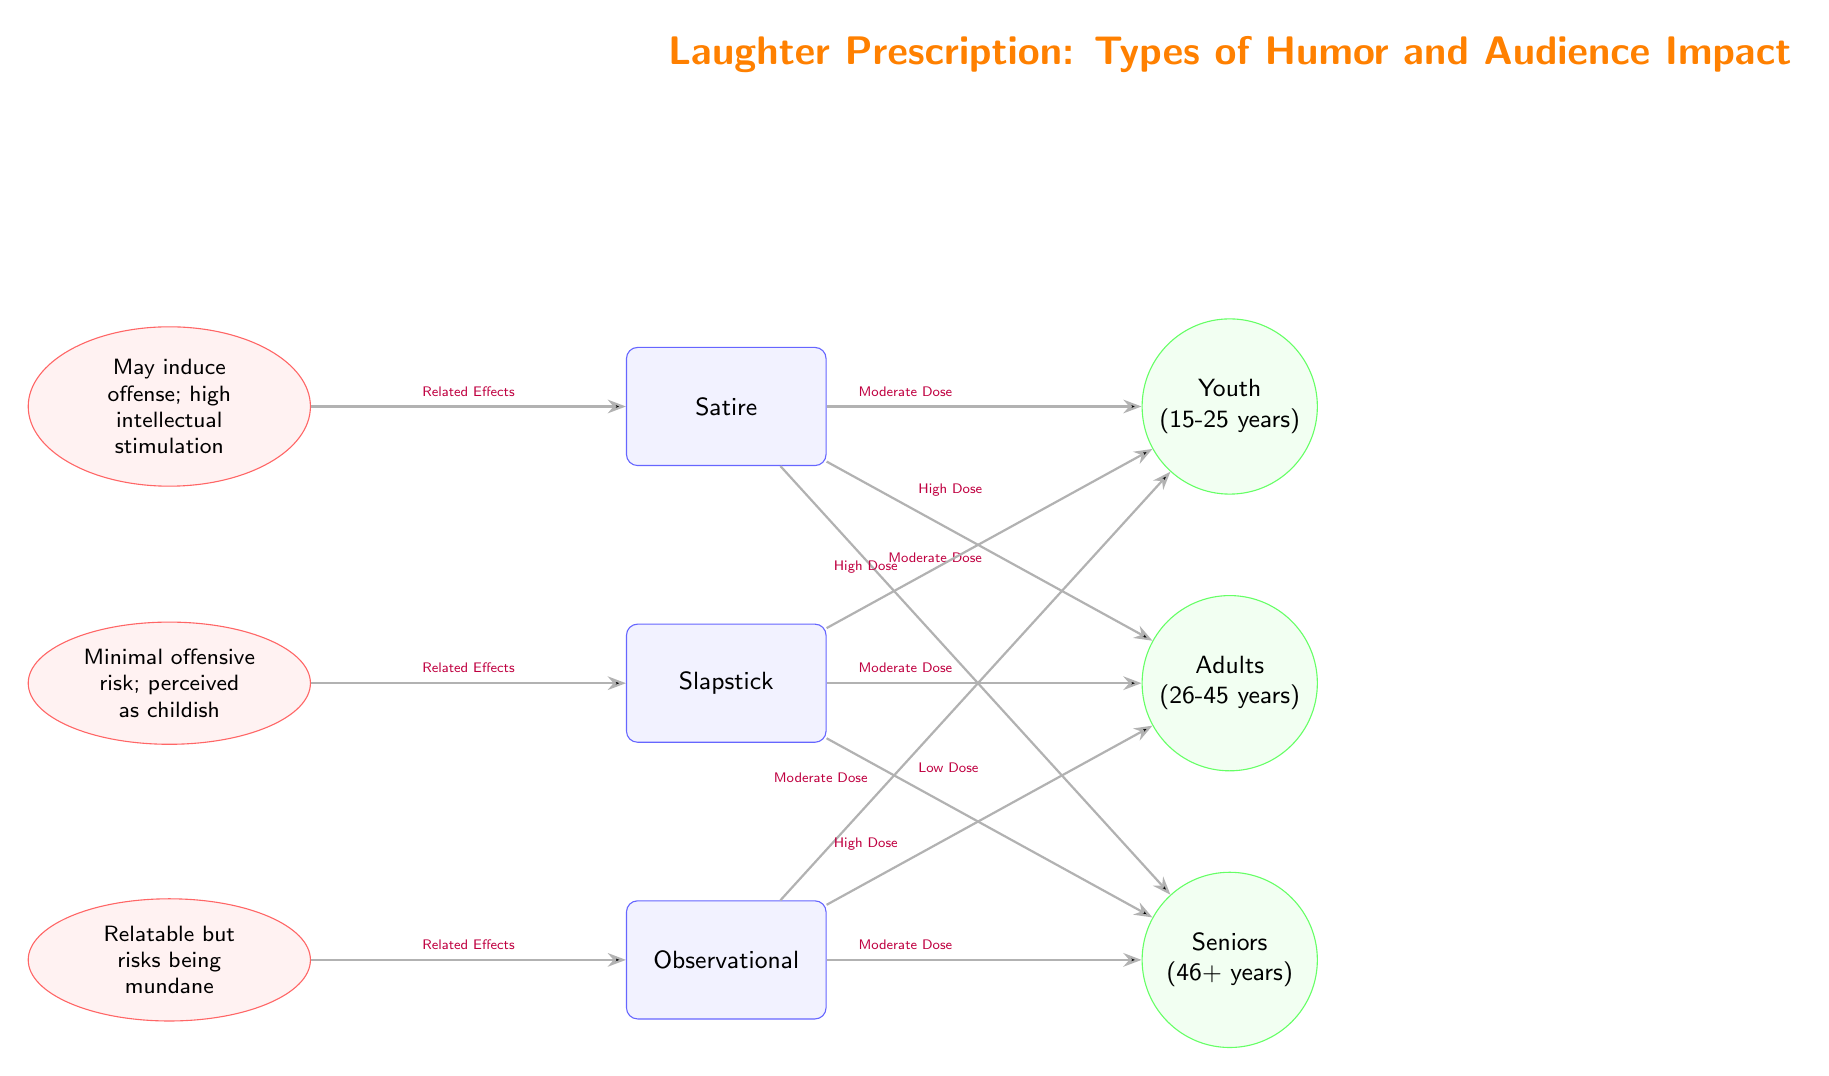What are the types of humor represented in the diagram? The diagram displays three types of humor: Satire, Slapstick, and Observational. This information is directly identifiable by examining the humor nodes at the top of the diagram.
Answer: Satire, Slapstick, Observational Which audience demographic is most likely to enjoy slapstick comedy in high doses? According to the connections depicted in the diagram, the Youth demographic is linked to slapstick comedy with a "High Dose." This relationship is established through the edge connecting the Slapstick node to the Youth node with the specified dose.
Answer: Youth What side effect is associated with satire? The node related to the side effects of satire directly states that it "May induce offense; high intellectual stimulation." This information is found in the side effect node linked to the Satire humor type.
Answer: May induce offense; high intellectual stimulation What is the required dose of observational humor for adults? The diagram indicates that the "High Dose" of observational humor is aimed at the Adults demographic, as shown by the edge connecting the Observational humor node to the Adults audience node and the label on the edge.
Answer: High Dose Which type of humor has minimal offensive risk according to the side effects? The side effect node corresponding to slapstick humor notes that there is "Minimal offensive risk; perceived as childish." This information is directly gleaned from the content of the side effect node linked to Slapstick.
Answer: Minimal offensive risk; perceived as childish For which demographic is slapstick humor administered in low doses? The diagram indicates that seniors receive slapstick humor in a "Low Dose," as indicated by the edge connecting the Slapstick humor node to the Seniors audience node specifying dose amount.
Answer: Seniors What common side effect does observational humor pose? The side effect node for observational humor mentions that it can be "Relatable but risks being mundane." This detail is explicitly labeled in the side effect node associated with Observational humor.
Answer: Relatable but risks being mundane Which humor type has the highest dosage for adults? The diagram shows that adults receive a "High Dose" of observational humor and a "High Dose" of satire, but among all humor types, observational humor is specifically directed at adults in high quantity as noted under the Observational connections.
Answer: Observational How many humor types are represented in the diagram? There are three humor types represented, which can be counted by simply identifying the nodes related to humor, confirming that each humor type is distinctly shown.
Answer: 3 